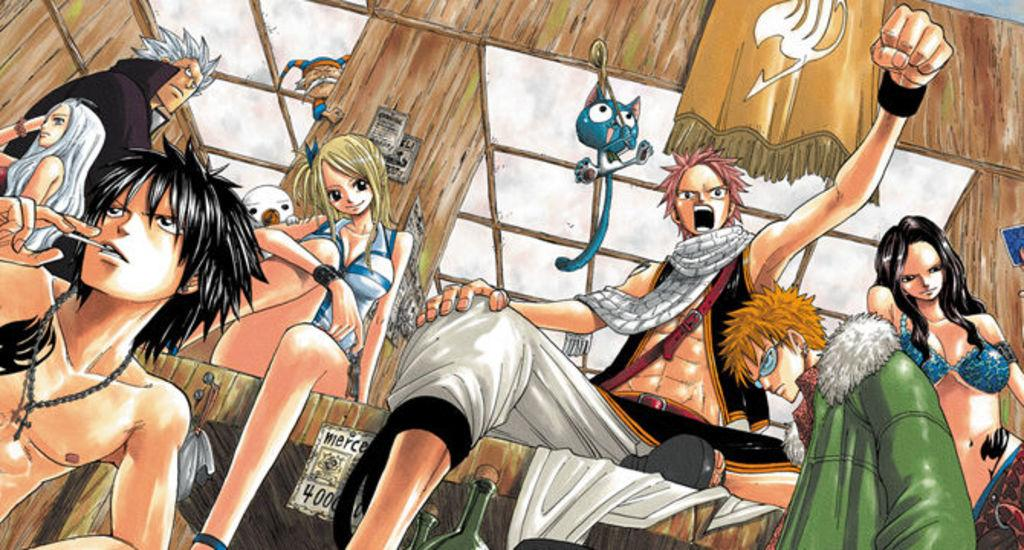How many persons are in the image? There are persons in the image, but the exact number is not specified. What type of structure is visible in the image? There is a house in the image. What animal is present in the image? There is a cat in the image. What is the board used for in the image? The purpose of the board in the image is not specified. Can you describe any other objects in the image? There are other objects in the image, but their specific details are not provided. What color is the cat's tongue in the image? There is no information about the cat's tongue in the image. 